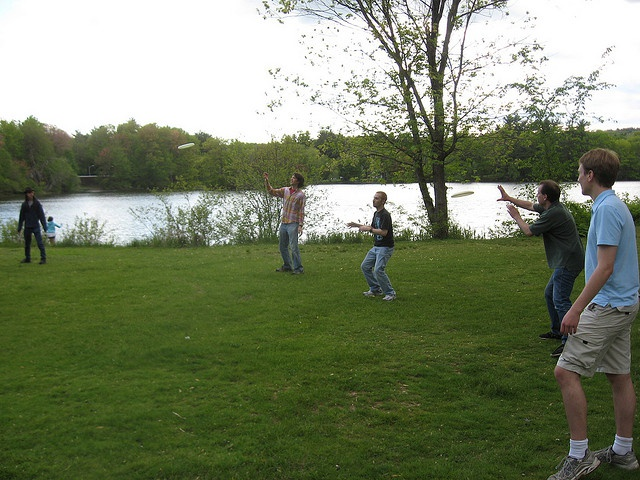Describe the objects in this image and their specific colors. I can see people in white, gray, and black tones, people in white, black, gray, and darkgreen tones, people in white, gray, black, darkgreen, and purple tones, people in white, black, gray, purple, and darkblue tones, and people in white, black, darkgreen, and gray tones in this image. 